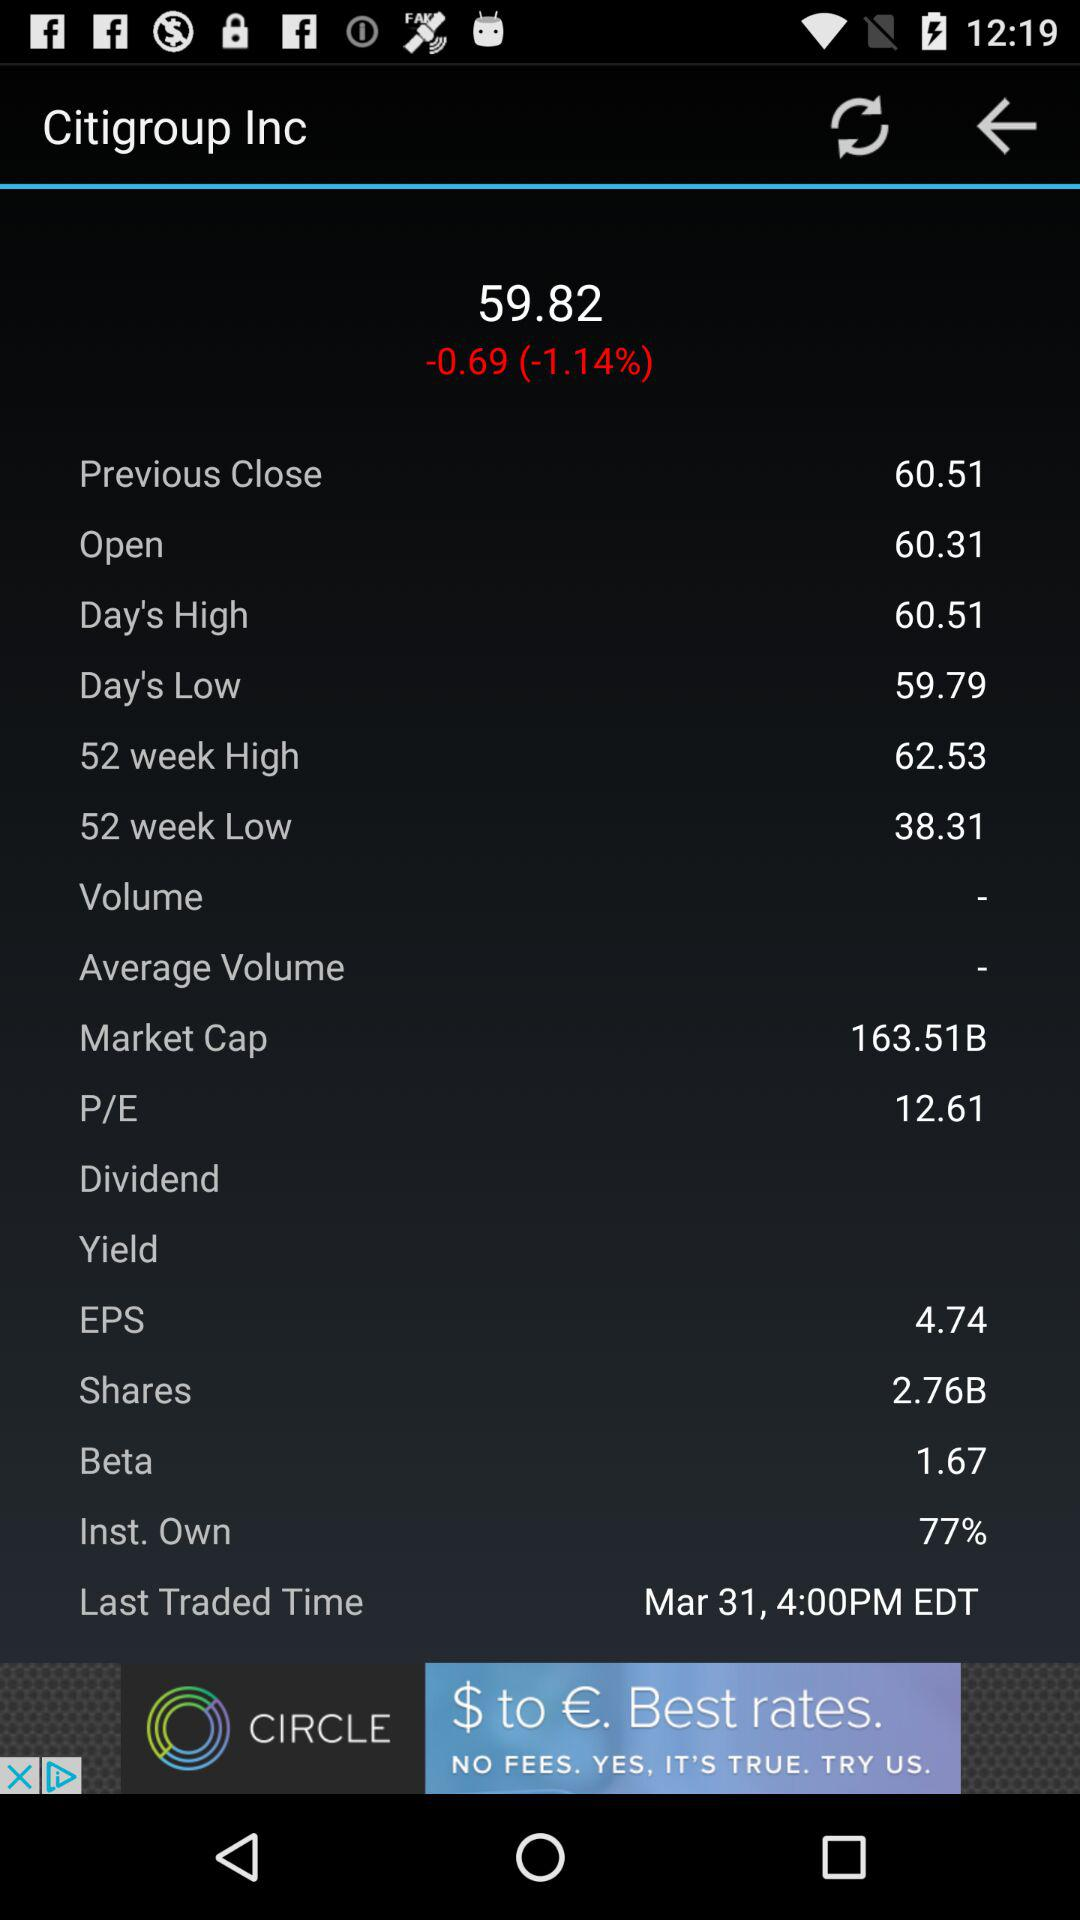How much is the difference between the 52 week high and low?
Answer the question using a single word or phrase. 24.22 